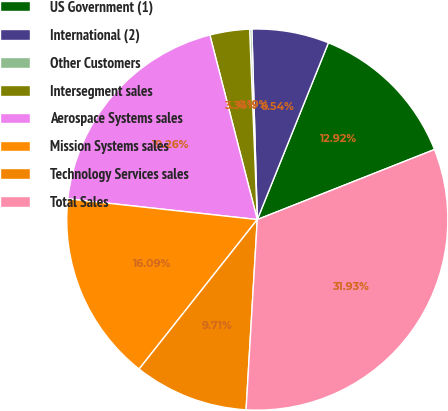Convert chart to OTSL. <chart><loc_0><loc_0><loc_500><loc_500><pie_chart><fcel>US Government (1)<fcel>International (2)<fcel>Other Customers<fcel>Intersegment sales<fcel>Aerospace Systems sales<fcel>Mission Systems sales<fcel>Technology Services sales<fcel>Total Sales<nl><fcel>12.92%<fcel>6.54%<fcel>0.19%<fcel>3.36%<fcel>19.26%<fcel>16.09%<fcel>9.71%<fcel>31.93%<nl></chart> 